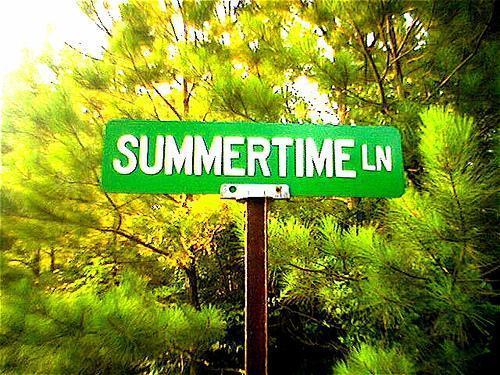How many street names are shown?
Give a very brief answer. 1. How many street signs are on the pole?
Give a very brief answer. 1. 